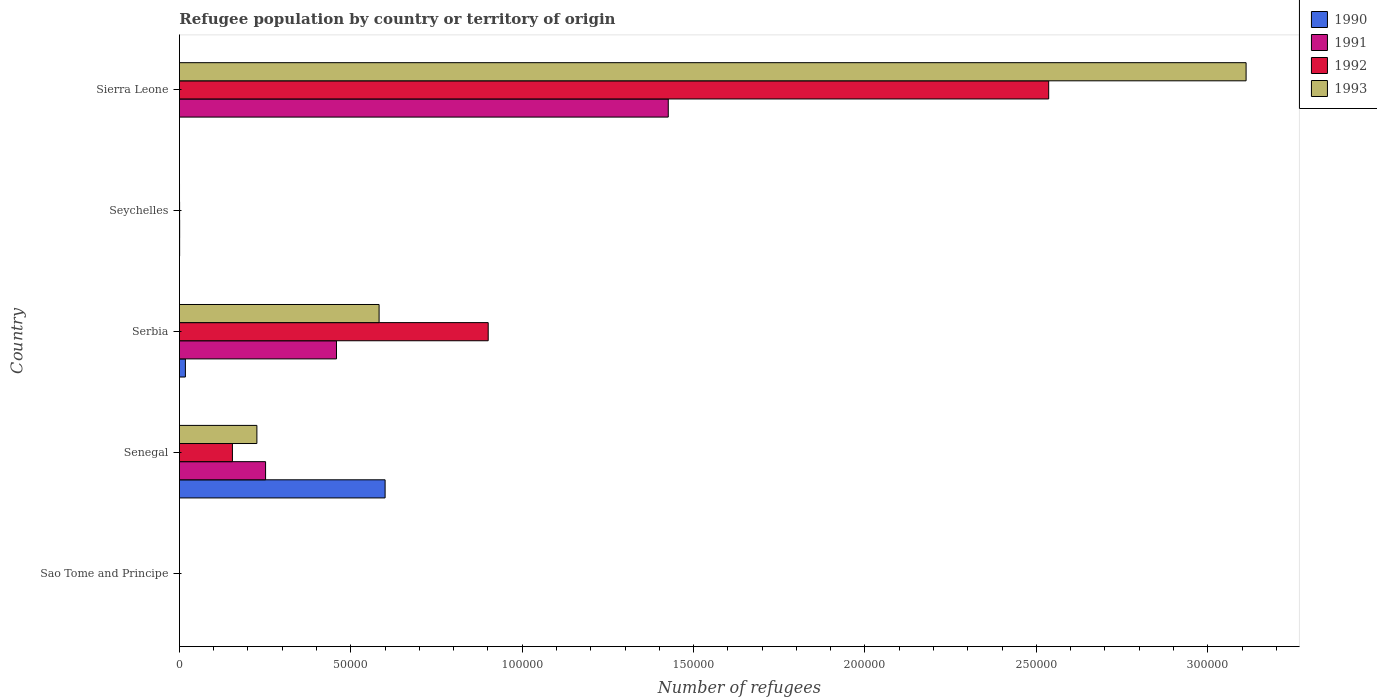How many different coloured bars are there?
Offer a very short reply. 4. Are the number of bars on each tick of the Y-axis equal?
Offer a terse response. Yes. What is the label of the 2nd group of bars from the top?
Ensure brevity in your answer.  Seychelles. In how many cases, is the number of bars for a given country not equal to the number of legend labels?
Your answer should be compact. 0. What is the number of refugees in 1992 in Seychelles?
Make the answer very short. 54. Across all countries, what is the maximum number of refugees in 1991?
Your answer should be compact. 1.43e+05. Across all countries, what is the minimum number of refugees in 1990?
Offer a very short reply. 1. In which country was the number of refugees in 1992 maximum?
Your response must be concise. Sierra Leone. In which country was the number of refugees in 1990 minimum?
Your response must be concise. Sao Tome and Principe. What is the total number of refugees in 1990 in the graph?
Your response must be concise. 6.18e+04. What is the difference between the number of refugees in 1990 in Serbia and that in Sierra Leone?
Give a very brief answer. 1736. What is the difference between the number of refugees in 1992 in Sierra Leone and the number of refugees in 1990 in Seychelles?
Your answer should be very brief. 2.54e+05. What is the average number of refugees in 1993 per country?
Keep it short and to the point. 7.84e+04. What is the difference between the number of refugees in 1993 and number of refugees in 1991 in Senegal?
Provide a succinct answer. -2537. In how many countries, is the number of refugees in 1991 greater than 10000 ?
Offer a very short reply. 3. What is the ratio of the number of refugees in 1991 in Sao Tome and Principe to that in Seychelles?
Make the answer very short. 0.01. Is the number of refugees in 1991 in Senegal less than that in Serbia?
Offer a terse response. Yes. What is the difference between the highest and the second highest number of refugees in 1991?
Provide a succinct answer. 9.68e+04. What is the difference between the highest and the lowest number of refugees in 1992?
Your response must be concise. 2.54e+05. In how many countries, is the number of refugees in 1991 greater than the average number of refugees in 1991 taken over all countries?
Give a very brief answer. 2. Is the sum of the number of refugees in 1992 in Senegal and Seychelles greater than the maximum number of refugees in 1990 across all countries?
Give a very brief answer. No. Is it the case that in every country, the sum of the number of refugees in 1992 and number of refugees in 1993 is greater than the sum of number of refugees in 1990 and number of refugees in 1991?
Keep it short and to the point. No. What does the 4th bar from the top in Sao Tome and Principe represents?
Keep it short and to the point. 1990. What does the 4th bar from the bottom in Sao Tome and Principe represents?
Your response must be concise. 1993. Is it the case that in every country, the sum of the number of refugees in 1993 and number of refugees in 1990 is greater than the number of refugees in 1991?
Ensure brevity in your answer.  Yes. How many bars are there?
Offer a terse response. 20. What is the difference between two consecutive major ticks on the X-axis?
Your answer should be compact. 5.00e+04. Does the graph contain any zero values?
Give a very brief answer. No. What is the title of the graph?
Provide a short and direct response. Refugee population by country or territory of origin. Does "1998" appear as one of the legend labels in the graph?
Give a very brief answer. No. What is the label or title of the X-axis?
Ensure brevity in your answer.  Number of refugees. What is the Number of refugees in 1992 in Sao Tome and Principe?
Offer a terse response. 1. What is the Number of refugees of 1993 in Sao Tome and Principe?
Your response must be concise. 1. What is the Number of refugees in 1990 in Senegal?
Keep it short and to the point. 6.00e+04. What is the Number of refugees of 1991 in Senegal?
Ensure brevity in your answer.  2.51e+04. What is the Number of refugees in 1992 in Senegal?
Offer a very short reply. 1.55e+04. What is the Number of refugees in 1993 in Senegal?
Provide a short and direct response. 2.26e+04. What is the Number of refugees of 1990 in Serbia?
Keep it short and to the point. 1745. What is the Number of refugees of 1991 in Serbia?
Offer a terse response. 4.58e+04. What is the Number of refugees in 1992 in Serbia?
Make the answer very short. 9.01e+04. What is the Number of refugees in 1993 in Serbia?
Your answer should be compact. 5.83e+04. What is the Number of refugees in 1990 in Seychelles?
Your response must be concise. 60. What is the Number of refugees in 1991 in Seychelles?
Keep it short and to the point. 69. What is the Number of refugees in 1992 in Seychelles?
Offer a very short reply. 54. What is the Number of refugees of 1990 in Sierra Leone?
Your answer should be very brief. 9. What is the Number of refugees of 1991 in Sierra Leone?
Your answer should be very brief. 1.43e+05. What is the Number of refugees in 1992 in Sierra Leone?
Your answer should be very brief. 2.54e+05. What is the Number of refugees in 1993 in Sierra Leone?
Provide a succinct answer. 3.11e+05. Across all countries, what is the maximum Number of refugees of 1990?
Give a very brief answer. 6.00e+04. Across all countries, what is the maximum Number of refugees in 1991?
Your answer should be compact. 1.43e+05. Across all countries, what is the maximum Number of refugees of 1992?
Ensure brevity in your answer.  2.54e+05. Across all countries, what is the maximum Number of refugees of 1993?
Offer a very short reply. 3.11e+05. Across all countries, what is the minimum Number of refugees in 1990?
Offer a very short reply. 1. Across all countries, what is the minimum Number of refugees in 1992?
Ensure brevity in your answer.  1. What is the total Number of refugees in 1990 in the graph?
Your answer should be compact. 6.18e+04. What is the total Number of refugees in 1991 in the graph?
Your answer should be very brief. 2.14e+05. What is the total Number of refugees in 1992 in the graph?
Provide a short and direct response. 3.59e+05. What is the total Number of refugees in 1993 in the graph?
Provide a short and direct response. 3.92e+05. What is the difference between the Number of refugees of 1990 in Sao Tome and Principe and that in Senegal?
Offer a terse response. -6.00e+04. What is the difference between the Number of refugees of 1991 in Sao Tome and Principe and that in Senegal?
Ensure brevity in your answer.  -2.51e+04. What is the difference between the Number of refugees in 1992 in Sao Tome and Principe and that in Senegal?
Your answer should be compact. -1.55e+04. What is the difference between the Number of refugees in 1993 in Sao Tome and Principe and that in Senegal?
Your answer should be compact. -2.26e+04. What is the difference between the Number of refugees in 1990 in Sao Tome and Principe and that in Serbia?
Ensure brevity in your answer.  -1744. What is the difference between the Number of refugees of 1991 in Sao Tome and Principe and that in Serbia?
Make the answer very short. -4.58e+04. What is the difference between the Number of refugees in 1992 in Sao Tome and Principe and that in Serbia?
Your answer should be very brief. -9.01e+04. What is the difference between the Number of refugees in 1993 in Sao Tome and Principe and that in Serbia?
Your answer should be very brief. -5.83e+04. What is the difference between the Number of refugees of 1990 in Sao Tome and Principe and that in Seychelles?
Your answer should be compact. -59. What is the difference between the Number of refugees in 1991 in Sao Tome and Principe and that in Seychelles?
Keep it short and to the point. -68. What is the difference between the Number of refugees in 1992 in Sao Tome and Principe and that in Seychelles?
Keep it short and to the point. -53. What is the difference between the Number of refugees in 1993 in Sao Tome and Principe and that in Seychelles?
Keep it short and to the point. -27. What is the difference between the Number of refugees in 1990 in Sao Tome and Principe and that in Sierra Leone?
Provide a succinct answer. -8. What is the difference between the Number of refugees in 1991 in Sao Tome and Principe and that in Sierra Leone?
Your response must be concise. -1.43e+05. What is the difference between the Number of refugees of 1992 in Sao Tome and Principe and that in Sierra Leone?
Offer a very short reply. -2.54e+05. What is the difference between the Number of refugees of 1993 in Sao Tome and Principe and that in Sierra Leone?
Provide a short and direct response. -3.11e+05. What is the difference between the Number of refugees in 1990 in Senegal and that in Serbia?
Your answer should be very brief. 5.83e+04. What is the difference between the Number of refugees in 1991 in Senegal and that in Serbia?
Keep it short and to the point. -2.07e+04. What is the difference between the Number of refugees in 1992 in Senegal and that in Serbia?
Keep it short and to the point. -7.46e+04. What is the difference between the Number of refugees of 1993 in Senegal and that in Serbia?
Your response must be concise. -3.57e+04. What is the difference between the Number of refugees of 1990 in Senegal and that in Seychelles?
Provide a succinct answer. 5.99e+04. What is the difference between the Number of refugees of 1991 in Senegal and that in Seychelles?
Ensure brevity in your answer.  2.51e+04. What is the difference between the Number of refugees in 1992 in Senegal and that in Seychelles?
Ensure brevity in your answer.  1.54e+04. What is the difference between the Number of refugees in 1993 in Senegal and that in Seychelles?
Provide a succinct answer. 2.26e+04. What is the difference between the Number of refugees in 1990 in Senegal and that in Sierra Leone?
Provide a succinct answer. 6.00e+04. What is the difference between the Number of refugees in 1991 in Senegal and that in Sierra Leone?
Your answer should be very brief. -1.17e+05. What is the difference between the Number of refugees of 1992 in Senegal and that in Sierra Leone?
Ensure brevity in your answer.  -2.38e+05. What is the difference between the Number of refugees of 1993 in Senegal and that in Sierra Leone?
Give a very brief answer. -2.89e+05. What is the difference between the Number of refugees in 1990 in Serbia and that in Seychelles?
Your answer should be compact. 1685. What is the difference between the Number of refugees in 1991 in Serbia and that in Seychelles?
Provide a succinct answer. 4.58e+04. What is the difference between the Number of refugees in 1992 in Serbia and that in Seychelles?
Give a very brief answer. 9.00e+04. What is the difference between the Number of refugees in 1993 in Serbia and that in Seychelles?
Provide a succinct answer. 5.82e+04. What is the difference between the Number of refugees of 1990 in Serbia and that in Sierra Leone?
Offer a very short reply. 1736. What is the difference between the Number of refugees in 1991 in Serbia and that in Sierra Leone?
Make the answer very short. -9.68e+04. What is the difference between the Number of refugees of 1992 in Serbia and that in Sierra Leone?
Offer a terse response. -1.64e+05. What is the difference between the Number of refugees of 1993 in Serbia and that in Sierra Leone?
Offer a terse response. -2.53e+05. What is the difference between the Number of refugees in 1991 in Seychelles and that in Sierra Leone?
Offer a very short reply. -1.43e+05. What is the difference between the Number of refugees of 1992 in Seychelles and that in Sierra Leone?
Your response must be concise. -2.54e+05. What is the difference between the Number of refugees of 1993 in Seychelles and that in Sierra Leone?
Your answer should be compact. -3.11e+05. What is the difference between the Number of refugees in 1990 in Sao Tome and Principe and the Number of refugees in 1991 in Senegal?
Offer a very short reply. -2.51e+04. What is the difference between the Number of refugees of 1990 in Sao Tome and Principe and the Number of refugees of 1992 in Senegal?
Provide a succinct answer. -1.55e+04. What is the difference between the Number of refugees in 1990 in Sao Tome and Principe and the Number of refugees in 1993 in Senegal?
Provide a short and direct response. -2.26e+04. What is the difference between the Number of refugees of 1991 in Sao Tome and Principe and the Number of refugees of 1992 in Senegal?
Your response must be concise. -1.55e+04. What is the difference between the Number of refugees of 1991 in Sao Tome and Principe and the Number of refugees of 1993 in Senegal?
Keep it short and to the point. -2.26e+04. What is the difference between the Number of refugees in 1992 in Sao Tome and Principe and the Number of refugees in 1993 in Senegal?
Offer a terse response. -2.26e+04. What is the difference between the Number of refugees of 1990 in Sao Tome and Principe and the Number of refugees of 1991 in Serbia?
Keep it short and to the point. -4.58e+04. What is the difference between the Number of refugees of 1990 in Sao Tome and Principe and the Number of refugees of 1992 in Serbia?
Ensure brevity in your answer.  -9.01e+04. What is the difference between the Number of refugees in 1990 in Sao Tome and Principe and the Number of refugees in 1993 in Serbia?
Offer a very short reply. -5.83e+04. What is the difference between the Number of refugees in 1991 in Sao Tome and Principe and the Number of refugees in 1992 in Serbia?
Offer a terse response. -9.01e+04. What is the difference between the Number of refugees of 1991 in Sao Tome and Principe and the Number of refugees of 1993 in Serbia?
Your answer should be very brief. -5.83e+04. What is the difference between the Number of refugees of 1992 in Sao Tome and Principe and the Number of refugees of 1993 in Serbia?
Your answer should be compact. -5.83e+04. What is the difference between the Number of refugees of 1990 in Sao Tome and Principe and the Number of refugees of 1991 in Seychelles?
Your answer should be compact. -68. What is the difference between the Number of refugees in 1990 in Sao Tome and Principe and the Number of refugees in 1992 in Seychelles?
Give a very brief answer. -53. What is the difference between the Number of refugees of 1991 in Sao Tome and Principe and the Number of refugees of 1992 in Seychelles?
Provide a succinct answer. -53. What is the difference between the Number of refugees in 1990 in Sao Tome and Principe and the Number of refugees in 1991 in Sierra Leone?
Your answer should be compact. -1.43e+05. What is the difference between the Number of refugees of 1990 in Sao Tome and Principe and the Number of refugees of 1992 in Sierra Leone?
Your response must be concise. -2.54e+05. What is the difference between the Number of refugees in 1990 in Sao Tome and Principe and the Number of refugees in 1993 in Sierra Leone?
Your answer should be compact. -3.11e+05. What is the difference between the Number of refugees of 1991 in Sao Tome and Principe and the Number of refugees of 1992 in Sierra Leone?
Make the answer very short. -2.54e+05. What is the difference between the Number of refugees in 1991 in Sao Tome and Principe and the Number of refugees in 1993 in Sierra Leone?
Make the answer very short. -3.11e+05. What is the difference between the Number of refugees of 1992 in Sao Tome and Principe and the Number of refugees of 1993 in Sierra Leone?
Offer a very short reply. -3.11e+05. What is the difference between the Number of refugees in 1990 in Senegal and the Number of refugees in 1991 in Serbia?
Ensure brevity in your answer.  1.42e+04. What is the difference between the Number of refugees of 1990 in Senegal and the Number of refugees of 1992 in Serbia?
Give a very brief answer. -3.01e+04. What is the difference between the Number of refugees of 1990 in Senegal and the Number of refugees of 1993 in Serbia?
Your answer should be compact. 1753. What is the difference between the Number of refugees of 1991 in Senegal and the Number of refugees of 1992 in Serbia?
Your response must be concise. -6.49e+04. What is the difference between the Number of refugees of 1991 in Senegal and the Number of refugees of 1993 in Serbia?
Offer a very short reply. -3.31e+04. What is the difference between the Number of refugees in 1992 in Senegal and the Number of refugees in 1993 in Serbia?
Ensure brevity in your answer.  -4.28e+04. What is the difference between the Number of refugees in 1990 in Senegal and the Number of refugees in 1991 in Seychelles?
Your response must be concise. 5.99e+04. What is the difference between the Number of refugees of 1990 in Senegal and the Number of refugees of 1992 in Seychelles?
Your answer should be very brief. 6.00e+04. What is the difference between the Number of refugees in 1990 in Senegal and the Number of refugees in 1993 in Seychelles?
Your answer should be very brief. 6.00e+04. What is the difference between the Number of refugees in 1991 in Senegal and the Number of refugees in 1992 in Seychelles?
Offer a very short reply. 2.51e+04. What is the difference between the Number of refugees in 1991 in Senegal and the Number of refugees in 1993 in Seychelles?
Your answer should be compact. 2.51e+04. What is the difference between the Number of refugees in 1992 in Senegal and the Number of refugees in 1993 in Seychelles?
Your answer should be compact. 1.54e+04. What is the difference between the Number of refugees of 1990 in Senegal and the Number of refugees of 1991 in Sierra Leone?
Offer a very short reply. -8.26e+04. What is the difference between the Number of refugees of 1990 in Senegal and the Number of refugees of 1992 in Sierra Leone?
Your response must be concise. -1.94e+05. What is the difference between the Number of refugees in 1990 in Senegal and the Number of refugees in 1993 in Sierra Leone?
Offer a terse response. -2.51e+05. What is the difference between the Number of refugees of 1991 in Senegal and the Number of refugees of 1992 in Sierra Leone?
Your response must be concise. -2.28e+05. What is the difference between the Number of refugees in 1991 in Senegal and the Number of refugees in 1993 in Sierra Leone?
Provide a short and direct response. -2.86e+05. What is the difference between the Number of refugees in 1992 in Senegal and the Number of refugees in 1993 in Sierra Leone?
Your answer should be very brief. -2.96e+05. What is the difference between the Number of refugees in 1990 in Serbia and the Number of refugees in 1991 in Seychelles?
Ensure brevity in your answer.  1676. What is the difference between the Number of refugees of 1990 in Serbia and the Number of refugees of 1992 in Seychelles?
Your answer should be very brief. 1691. What is the difference between the Number of refugees in 1990 in Serbia and the Number of refugees in 1993 in Seychelles?
Provide a succinct answer. 1717. What is the difference between the Number of refugees in 1991 in Serbia and the Number of refugees in 1992 in Seychelles?
Your answer should be compact. 4.58e+04. What is the difference between the Number of refugees in 1991 in Serbia and the Number of refugees in 1993 in Seychelles?
Give a very brief answer. 4.58e+04. What is the difference between the Number of refugees in 1992 in Serbia and the Number of refugees in 1993 in Seychelles?
Make the answer very short. 9.01e+04. What is the difference between the Number of refugees of 1990 in Serbia and the Number of refugees of 1991 in Sierra Leone?
Your response must be concise. -1.41e+05. What is the difference between the Number of refugees of 1990 in Serbia and the Number of refugees of 1992 in Sierra Leone?
Make the answer very short. -2.52e+05. What is the difference between the Number of refugees of 1990 in Serbia and the Number of refugees of 1993 in Sierra Leone?
Your answer should be very brief. -3.09e+05. What is the difference between the Number of refugees of 1991 in Serbia and the Number of refugees of 1992 in Sierra Leone?
Keep it short and to the point. -2.08e+05. What is the difference between the Number of refugees in 1991 in Serbia and the Number of refugees in 1993 in Sierra Leone?
Offer a very short reply. -2.65e+05. What is the difference between the Number of refugees in 1992 in Serbia and the Number of refugees in 1993 in Sierra Leone?
Give a very brief answer. -2.21e+05. What is the difference between the Number of refugees in 1990 in Seychelles and the Number of refugees in 1991 in Sierra Leone?
Ensure brevity in your answer.  -1.43e+05. What is the difference between the Number of refugees of 1990 in Seychelles and the Number of refugees of 1992 in Sierra Leone?
Your answer should be very brief. -2.54e+05. What is the difference between the Number of refugees in 1990 in Seychelles and the Number of refugees in 1993 in Sierra Leone?
Give a very brief answer. -3.11e+05. What is the difference between the Number of refugees in 1991 in Seychelles and the Number of refugees in 1992 in Sierra Leone?
Your answer should be very brief. -2.54e+05. What is the difference between the Number of refugees of 1991 in Seychelles and the Number of refugees of 1993 in Sierra Leone?
Provide a succinct answer. -3.11e+05. What is the difference between the Number of refugees of 1992 in Seychelles and the Number of refugees of 1993 in Sierra Leone?
Ensure brevity in your answer.  -3.11e+05. What is the average Number of refugees of 1990 per country?
Give a very brief answer. 1.24e+04. What is the average Number of refugees in 1991 per country?
Provide a succinct answer. 4.27e+04. What is the average Number of refugees of 1992 per country?
Offer a very short reply. 7.18e+04. What is the average Number of refugees in 1993 per country?
Give a very brief answer. 7.84e+04. What is the difference between the Number of refugees of 1990 and Number of refugees of 1992 in Sao Tome and Principe?
Keep it short and to the point. 0. What is the difference between the Number of refugees of 1990 and Number of refugees of 1993 in Sao Tome and Principe?
Offer a very short reply. 0. What is the difference between the Number of refugees in 1991 and Number of refugees in 1993 in Sao Tome and Principe?
Make the answer very short. 0. What is the difference between the Number of refugees in 1992 and Number of refugees in 1993 in Sao Tome and Principe?
Offer a very short reply. 0. What is the difference between the Number of refugees in 1990 and Number of refugees in 1991 in Senegal?
Ensure brevity in your answer.  3.49e+04. What is the difference between the Number of refugees of 1990 and Number of refugees of 1992 in Senegal?
Your answer should be compact. 4.45e+04. What is the difference between the Number of refugees in 1990 and Number of refugees in 1993 in Senegal?
Make the answer very short. 3.74e+04. What is the difference between the Number of refugees in 1991 and Number of refugees in 1992 in Senegal?
Provide a short and direct response. 9672. What is the difference between the Number of refugees in 1991 and Number of refugees in 1993 in Senegal?
Provide a short and direct response. 2537. What is the difference between the Number of refugees in 1992 and Number of refugees in 1993 in Senegal?
Provide a short and direct response. -7135. What is the difference between the Number of refugees in 1990 and Number of refugees in 1991 in Serbia?
Your response must be concise. -4.41e+04. What is the difference between the Number of refugees in 1990 and Number of refugees in 1992 in Serbia?
Offer a very short reply. -8.83e+04. What is the difference between the Number of refugees of 1990 and Number of refugees of 1993 in Serbia?
Your answer should be compact. -5.65e+04. What is the difference between the Number of refugees of 1991 and Number of refugees of 1992 in Serbia?
Make the answer very short. -4.43e+04. What is the difference between the Number of refugees of 1991 and Number of refugees of 1993 in Serbia?
Provide a succinct answer. -1.24e+04. What is the difference between the Number of refugees of 1992 and Number of refugees of 1993 in Serbia?
Make the answer very short. 3.18e+04. What is the difference between the Number of refugees in 1990 and Number of refugees in 1991 in Seychelles?
Provide a succinct answer. -9. What is the difference between the Number of refugees in 1990 and Number of refugees in 1993 in Seychelles?
Make the answer very short. 32. What is the difference between the Number of refugees of 1991 and Number of refugees of 1993 in Seychelles?
Give a very brief answer. 41. What is the difference between the Number of refugees in 1990 and Number of refugees in 1991 in Sierra Leone?
Make the answer very short. -1.43e+05. What is the difference between the Number of refugees of 1990 and Number of refugees of 1992 in Sierra Leone?
Offer a very short reply. -2.54e+05. What is the difference between the Number of refugees in 1990 and Number of refugees in 1993 in Sierra Leone?
Your answer should be compact. -3.11e+05. What is the difference between the Number of refugees of 1991 and Number of refugees of 1992 in Sierra Leone?
Provide a succinct answer. -1.11e+05. What is the difference between the Number of refugees of 1991 and Number of refugees of 1993 in Sierra Leone?
Your answer should be compact. -1.69e+05. What is the difference between the Number of refugees of 1992 and Number of refugees of 1993 in Sierra Leone?
Provide a short and direct response. -5.76e+04. What is the ratio of the Number of refugees in 1992 in Sao Tome and Principe to that in Senegal?
Give a very brief answer. 0. What is the ratio of the Number of refugees of 1990 in Sao Tome and Principe to that in Serbia?
Ensure brevity in your answer.  0. What is the ratio of the Number of refugees in 1990 in Sao Tome and Principe to that in Seychelles?
Make the answer very short. 0.02. What is the ratio of the Number of refugees of 1991 in Sao Tome and Principe to that in Seychelles?
Keep it short and to the point. 0.01. What is the ratio of the Number of refugees of 1992 in Sao Tome and Principe to that in Seychelles?
Give a very brief answer. 0.02. What is the ratio of the Number of refugees in 1993 in Sao Tome and Principe to that in Seychelles?
Offer a terse response. 0.04. What is the ratio of the Number of refugees in 1990 in Sao Tome and Principe to that in Sierra Leone?
Make the answer very short. 0.11. What is the ratio of the Number of refugees in 1991 in Sao Tome and Principe to that in Sierra Leone?
Keep it short and to the point. 0. What is the ratio of the Number of refugees in 1992 in Sao Tome and Principe to that in Sierra Leone?
Your answer should be compact. 0. What is the ratio of the Number of refugees of 1990 in Senegal to that in Serbia?
Provide a succinct answer. 34.39. What is the ratio of the Number of refugees in 1991 in Senegal to that in Serbia?
Make the answer very short. 0.55. What is the ratio of the Number of refugees in 1992 in Senegal to that in Serbia?
Make the answer very short. 0.17. What is the ratio of the Number of refugees in 1993 in Senegal to that in Serbia?
Ensure brevity in your answer.  0.39. What is the ratio of the Number of refugees in 1990 in Senegal to that in Seychelles?
Your response must be concise. 1000.1. What is the ratio of the Number of refugees in 1991 in Senegal to that in Seychelles?
Offer a terse response. 364.32. What is the ratio of the Number of refugees in 1992 in Senegal to that in Seychelles?
Your answer should be compact. 286.41. What is the ratio of the Number of refugees in 1993 in Senegal to that in Seychelles?
Offer a very short reply. 807.18. What is the ratio of the Number of refugees in 1990 in Senegal to that in Sierra Leone?
Provide a succinct answer. 6667.33. What is the ratio of the Number of refugees in 1991 in Senegal to that in Sierra Leone?
Give a very brief answer. 0.18. What is the ratio of the Number of refugees of 1992 in Senegal to that in Sierra Leone?
Your answer should be compact. 0.06. What is the ratio of the Number of refugees in 1993 in Senegal to that in Sierra Leone?
Keep it short and to the point. 0.07. What is the ratio of the Number of refugees of 1990 in Serbia to that in Seychelles?
Provide a short and direct response. 29.08. What is the ratio of the Number of refugees in 1991 in Serbia to that in Seychelles?
Your answer should be very brief. 664.1. What is the ratio of the Number of refugees in 1992 in Serbia to that in Seychelles?
Offer a very short reply. 1668.17. What is the ratio of the Number of refugees in 1993 in Serbia to that in Seychelles?
Provide a short and direct response. 2080.46. What is the ratio of the Number of refugees in 1990 in Serbia to that in Sierra Leone?
Your answer should be very brief. 193.89. What is the ratio of the Number of refugees of 1991 in Serbia to that in Sierra Leone?
Your answer should be very brief. 0.32. What is the ratio of the Number of refugees in 1992 in Serbia to that in Sierra Leone?
Provide a succinct answer. 0.36. What is the ratio of the Number of refugees of 1993 in Serbia to that in Sierra Leone?
Your response must be concise. 0.19. What is the ratio of the Number of refugees in 1991 in Seychelles to that in Sierra Leone?
Offer a very short reply. 0. What is the difference between the highest and the second highest Number of refugees of 1990?
Offer a terse response. 5.83e+04. What is the difference between the highest and the second highest Number of refugees in 1991?
Your answer should be compact. 9.68e+04. What is the difference between the highest and the second highest Number of refugees in 1992?
Give a very brief answer. 1.64e+05. What is the difference between the highest and the second highest Number of refugees of 1993?
Provide a succinct answer. 2.53e+05. What is the difference between the highest and the lowest Number of refugees in 1990?
Offer a very short reply. 6.00e+04. What is the difference between the highest and the lowest Number of refugees of 1991?
Your response must be concise. 1.43e+05. What is the difference between the highest and the lowest Number of refugees in 1992?
Make the answer very short. 2.54e+05. What is the difference between the highest and the lowest Number of refugees of 1993?
Offer a terse response. 3.11e+05. 